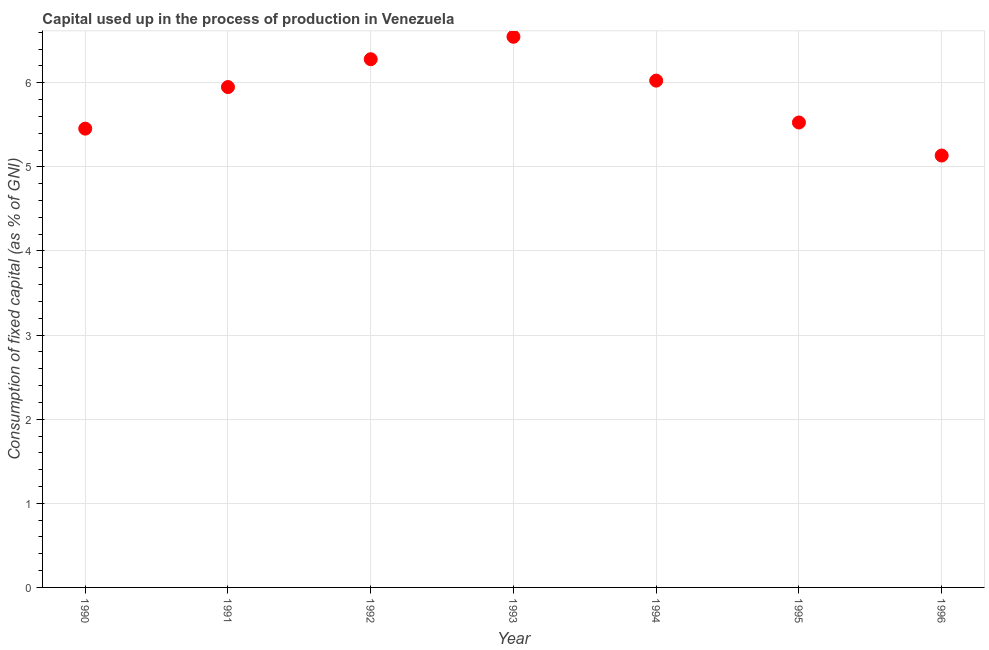What is the consumption of fixed capital in 1990?
Your answer should be compact. 5.45. Across all years, what is the maximum consumption of fixed capital?
Your answer should be compact. 6.55. Across all years, what is the minimum consumption of fixed capital?
Ensure brevity in your answer.  5.13. What is the sum of the consumption of fixed capital?
Ensure brevity in your answer.  40.92. What is the difference between the consumption of fixed capital in 1994 and 1995?
Offer a terse response. 0.5. What is the average consumption of fixed capital per year?
Give a very brief answer. 5.85. What is the median consumption of fixed capital?
Your response must be concise. 5.95. What is the ratio of the consumption of fixed capital in 1992 to that in 1996?
Keep it short and to the point. 1.22. What is the difference between the highest and the second highest consumption of fixed capital?
Give a very brief answer. 0.27. Is the sum of the consumption of fixed capital in 1992 and 1993 greater than the maximum consumption of fixed capital across all years?
Your response must be concise. Yes. What is the difference between the highest and the lowest consumption of fixed capital?
Your answer should be compact. 1.41. In how many years, is the consumption of fixed capital greater than the average consumption of fixed capital taken over all years?
Keep it short and to the point. 4. Does the consumption of fixed capital monotonically increase over the years?
Keep it short and to the point. No. What is the title of the graph?
Keep it short and to the point. Capital used up in the process of production in Venezuela. What is the label or title of the Y-axis?
Provide a succinct answer. Consumption of fixed capital (as % of GNI). What is the Consumption of fixed capital (as % of GNI) in 1990?
Ensure brevity in your answer.  5.45. What is the Consumption of fixed capital (as % of GNI) in 1991?
Ensure brevity in your answer.  5.95. What is the Consumption of fixed capital (as % of GNI) in 1992?
Keep it short and to the point. 6.28. What is the Consumption of fixed capital (as % of GNI) in 1993?
Make the answer very short. 6.55. What is the Consumption of fixed capital (as % of GNI) in 1994?
Your answer should be very brief. 6.03. What is the Consumption of fixed capital (as % of GNI) in 1995?
Your response must be concise. 5.53. What is the Consumption of fixed capital (as % of GNI) in 1996?
Your answer should be compact. 5.13. What is the difference between the Consumption of fixed capital (as % of GNI) in 1990 and 1991?
Give a very brief answer. -0.49. What is the difference between the Consumption of fixed capital (as % of GNI) in 1990 and 1992?
Keep it short and to the point. -0.83. What is the difference between the Consumption of fixed capital (as % of GNI) in 1990 and 1993?
Offer a terse response. -1.09. What is the difference between the Consumption of fixed capital (as % of GNI) in 1990 and 1994?
Give a very brief answer. -0.57. What is the difference between the Consumption of fixed capital (as % of GNI) in 1990 and 1995?
Give a very brief answer. -0.07. What is the difference between the Consumption of fixed capital (as % of GNI) in 1990 and 1996?
Provide a short and direct response. 0.32. What is the difference between the Consumption of fixed capital (as % of GNI) in 1991 and 1992?
Keep it short and to the point. -0.33. What is the difference between the Consumption of fixed capital (as % of GNI) in 1991 and 1993?
Offer a terse response. -0.6. What is the difference between the Consumption of fixed capital (as % of GNI) in 1991 and 1994?
Your response must be concise. -0.08. What is the difference between the Consumption of fixed capital (as % of GNI) in 1991 and 1995?
Your answer should be compact. 0.42. What is the difference between the Consumption of fixed capital (as % of GNI) in 1991 and 1996?
Your answer should be very brief. 0.81. What is the difference between the Consumption of fixed capital (as % of GNI) in 1992 and 1993?
Offer a very short reply. -0.27. What is the difference between the Consumption of fixed capital (as % of GNI) in 1992 and 1994?
Your answer should be compact. 0.25. What is the difference between the Consumption of fixed capital (as % of GNI) in 1992 and 1995?
Your answer should be compact. 0.75. What is the difference between the Consumption of fixed capital (as % of GNI) in 1992 and 1996?
Ensure brevity in your answer.  1.15. What is the difference between the Consumption of fixed capital (as % of GNI) in 1993 and 1994?
Give a very brief answer. 0.52. What is the difference between the Consumption of fixed capital (as % of GNI) in 1993 and 1995?
Your answer should be very brief. 1.02. What is the difference between the Consumption of fixed capital (as % of GNI) in 1993 and 1996?
Your answer should be compact. 1.41. What is the difference between the Consumption of fixed capital (as % of GNI) in 1994 and 1995?
Give a very brief answer. 0.5. What is the difference between the Consumption of fixed capital (as % of GNI) in 1994 and 1996?
Keep it short and to the point. 0.89. What is the difference between the Consumption of fixed capital (as % of GNI) in 1995 and 1996?
Make the answer very short. 0.39. What is the ratio of the Consumption of fixed capital (as % of GNI) in 1990 to that in 1991?
Make the answer very short. 0.92. What is the ratio of the Consumption of fixed capital (as % of GNI) in 1990 to that in 1992?
Your answer should be very brief. 0.87. What is the ratio of the Consumption of fixed capital (as % of GNI) in 1990 to that in 1993?
Your response must be concise. 0.83. What is the ratio of the Consumption of fixed capital (as % of GNI) in 1990 to that in 1994?
Your response must be concise. 0.91. What is the ratio of the Consumption of fixed capital (as % of GNI) in 1990 to that in 1996?
Your answer should be compact. 1.06. What is the ratio of the Consumption of fixed capital (as % of GNI) in 1991 to that in 1992?
Give a very brief answer. 0.95. What is the ratio of the Consumption of fixed capital (as % of GNI) in 1991 to that in 1993?
Ensure brevity in your answer.  0.91. What is the ratio of the Consumption of fixed capital (as % of GNI) in 1991 to that in 1994?
Offer a very short reply. 0.99. What is the ratio of the Consumption of fixed capital (as % of GNI) in 1991 to that in 1995?
Make the answer very short. 1.08. What is the ratio of the Consumption of fixed capital (as % of GNI) in 1991 to that in 1996?
Keep it short and to the point. 1.16. What is the ratio of the Consumption of fixed capital (as % of GNI) in 1992 to that in 1994?
Provide a succinct answer. 1.04. What is the ratio of the Consumption of fixed capital (as % of GNI) in 1992 to that in 1995?
Your response must be concise. 1.14. What is the ratio of the Consumption of fixed capital (as % of GNI) in 1992 to that in 1996?
Provide a short and direct response. 1.22. What is the ratio of the Consumption of fixed capital (as % of GNI) in 1993 to that in 1994?
Offer a very short reply. 1.09. What is the ratio of the Consumption of fixed capital (as % of GNI) in 1993 to that in 1995?
Your answer should be compact. 1.18. What is the ratio of the Consumption of fixed capital (as % of GNI) in 1993 to that in 1996?
Your answer should be compact. 1.27. What is the ratio of the Consumption of fixed capital (as % of GNI) in 1994 to that in 1995?
Keep it short and to the point. 1.09. What is the ratio of the Consumption of fixed capital (as % of GNI) in 1994 to that in 1996?
Your answer should be very brief. 1.17. What is the ratio of the Consumption of fixed capital (as % of GNI) in 1995 to that in 1996?
Provide a succinct answer. 1.08. 